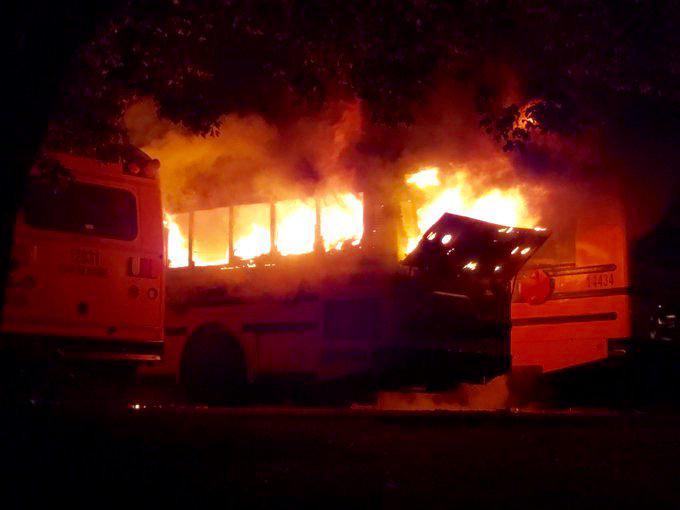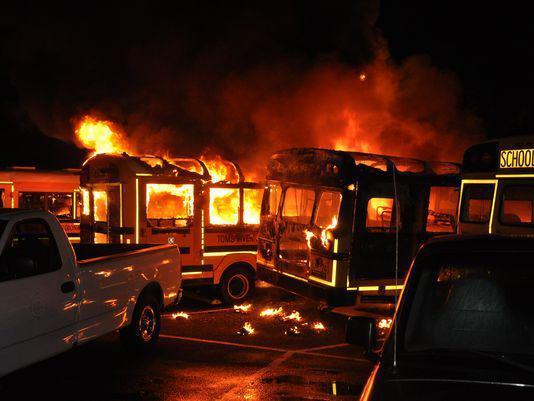The first image is the image on the left, the second image is the image on the right. Assess this claim about the two images: "One image shows a school bus on fire, and the other does not.". Correct or not? Answer yes or no. No. The first image is the image on the left, the second image is the image on the right. For the images displayed, is the sentence "At least one school bus is on fire in only one of the images." factually correct? Answer yes or no. No. 